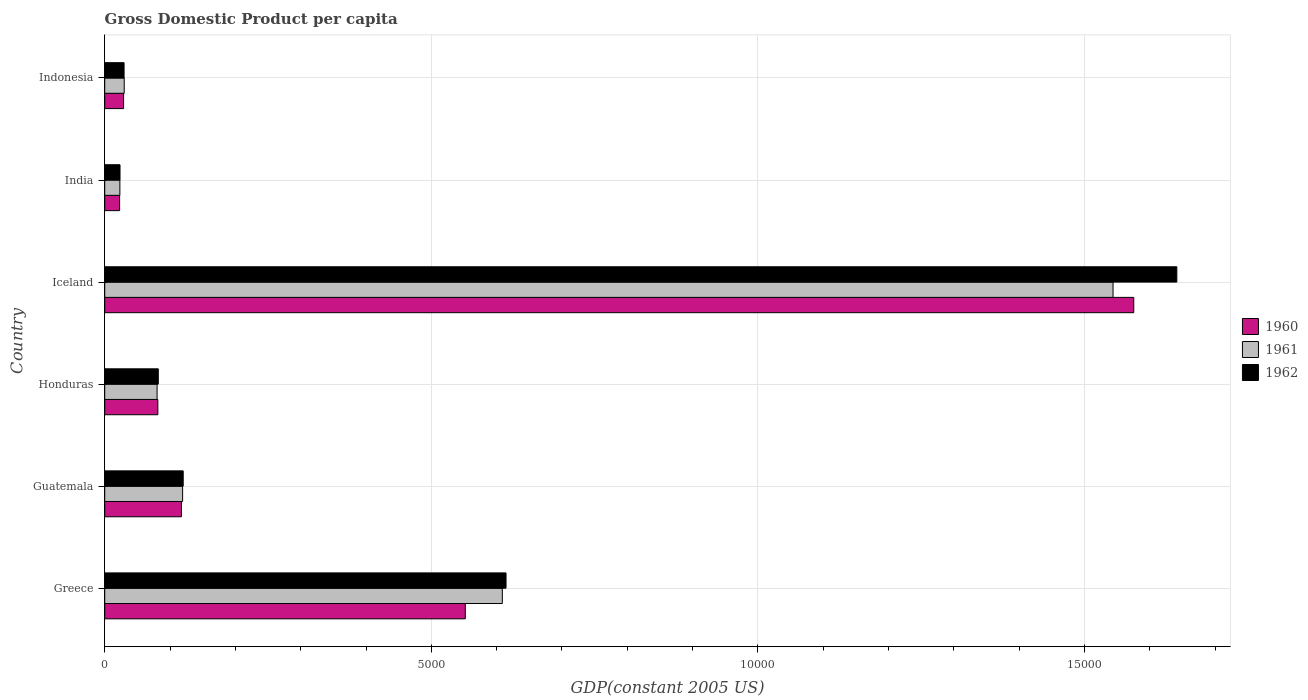How many groups of bars are there?
Keep it short and to the point. 6. Are the number of bars on each tick of the Y-axis equal?
Offer a terse response. Yes. How many bars are there on the 4th tick from the top?
Make the answer very short. 3. How many bars are there on the 4th tick from the bottom?
Your answer should be very brief. 3. What is the label of the 1st group of bars from the top?
Give a very brief answer. Indonesia. What is the GDP per capita in 1960 in Honduras?
Your answer should be compact. 813.41. Across all countries, what is the maximum GDP per capita in 1960?
Your response must be concise. 1.58e+04. Across all countries, what is the minimum GDP per capita in 1962?
Your answer should be compact. 234.17. What is the total GDP per capita in 1961 in the graph?
Provide a short and direct response. 2.40e+04. What is the difference between the GDP per capita in 1962 in Honduras and that in Iceland?
Ensure brevity in your answer.  -1.56e+04. What is the difference between the GDP per capita in 1962 in Honduras and the GDP per capita in 1961 in Indonesia?
Provide a succinct answer. 521.57. What is the average GDP per capita in 1961 per country?
Your answer should be very brief. 4008.09. What is the difference between the GDP per capita in 1961 and GDP per capita in 1962 in India?
Provide a short and direct response. -2.02. In how many countries, is the GDP per capita in 1960 greater than 13000 US$?
Make the answer very short. 1. What is the ratio of the GDP per capita in 1961 in Greece to that in India?
Your answer should be compact. 26.22. Is the difference between the GDP per capita in 1961 in Honduras and Indonesia greater than the difference between the GDP per capita in 1962 in Honduras and Indonesia?
Make the answer very short. No. What is the difference between the highest and the second highest GDP per capita in 1961?
Provide a succinct answer. 9349.4. What is the difference between the highest and the lowest GDP per capita in 1962?
Your answer should be very brief. 1.62e+04. In how many countries, is the GDP per capita in 1960 greater than the average GDP per capita in 1960 taken over all countries?
Your answer should be very brief. 2. Is the sum of the GDP per capita in 1961 in Greece and India greater than the maximum GDP per capita in 1960 across all countries?
Ensure brevity in your answer.  No. What does the 2nd bar from the top in Iceland represents?
Ensure brevity in your answer.  1961. What does the 1st bar from the bottom in Honduras represents?
Your answer should be very brief. 1960. Does the graph contain grids?
Offer a terse response. Yes. Where does the legend appear in the graph?
Offer a terse response. Center right. How are the legend labels stacked?
Ensure brevity in your answer.  Vertical. What is the title of the graph?
Make the answer very short. Gross Domestic Product per capita. Does "1995" appear as one of the legend labels in the graph?
Provide a short and direct response. No. What is the label or title of the X-axis?
Your answer should be very brief. GDP(constant 2005 US). What is the GDP(constant 2005 US) of 1960 in Greece?
Your response must be concise. 5520.09. What is the GDP(constant 2005 US) in 1961 in Greece?
Make the answer very short. 6087.1. What is the GDP(constant 2005 US) of 1962 in Greece?
Give a very brief answer. 6143.73. What is the GDP(constant 2005 US) in 1960 in Guatemala?
Your answer should be very brief. 1174.44. What is the GDP(constant 2005 US) of 1961 in Guatemala?
Provide a short and direct response. 1192.42. What is the GDP(constant 2005 US) in 1962 in Guatemala?
Offer a very short reply. 1201.57. What is the GDP(constant 2005 US) of 1960 in Honduras?
Make the answer very short. 813.41. What is the GDP(constant 2005 US) of 1961 in Honduras?
Ensure brevity in your answer.  801.77. What is the GDP(constant 2005 US) in 1962 in Honduras?
Offer a terse response. 820.2. What is the GDP(constant 2005 US) in 1960 in Iceland?
Ensure brevity in your answer.  1.58e+04. What is the GDP(constant 2005 US) of 1961 in Iceland?
Your answer should be compact. 1.54e+04. What is the GDP(constant 2005 US) in 1962 in Iceland?
Your response must be concise. 1.64e+04. What is the GDP(constant 2005 US) of 1960 in India?
Offer a very short reply. 228.3. What is the GDP(constant 2005 US) of 1961 in India?
Keep it short and to the point. 232.14. What is the GDP(constant 2005 US) in 1962 in India?
Provide a short and direct response. 234.17. What is the GDP(constant 2005 US) in 1960 in Indonesia?
Your response must be concise. 288.96. What is the GDP(constant 2005 US) of 1961 in Indonesia?
Make the answer very short. 298.63. What is the GDP(constant 2005 US) of 1962 in Indonesia?
Your response must be concise. 296.37. Across all countries, what is the maximum GDP(constant 2005 US) of 1960?
Keep it short and to the point. 1.58e+04. Across all countries, what is the maximum GDP(constant 2005 US) of 1961?
Provide a short and direct response. 1.54e+04. Across all countries, what is the maximum GDP(constant 2005 US) in 1962?
Ensure brevity in your answer.  1.64e+04. Across all countries, what is the minimum GDP(constant 2005 US) of 1960?
Provide a short and direct response. 228.3. Across all countries, what is the minimum GDP(constant 2005 US) in 1961?
Offer a very short reply. 232.14. Across all countries, what is the minimum GDP(constant 2005 US) of 1962?
Give a very brief answer. 234.17. What is the total GDP(constant 2005 US) of 1960 in the graph?
Provide a short and direct response. 2.38e+04. What is the total GDP(constant 2005 US) in 1961 in the graph?
Your answer should be very brief. 2.40e+04. What is the total GDP(constant 2005 US) in 1962 in the graph?
Your answer should be compact. 2.51e+04. What is the difference between the GDP(constant 2005 US) of 1960 in Greece and that in Guatemala?
Your response must be concise. 4345.65. What is the difference between the GDP(constant 2005 US) in 1961 in Greece and that in Guatemala?
Make the answer very short. 4894.68. What is the difference between the GDP(constant 2005 US) in 1962 in Greece and that in Guatemala?
Provide a succinct answer. 4942.16. What is the difference between the GDP(constant 2005 US) in 1960 in Greece and that in Honduras?
Provide a short and direct response. 4706.68. What is the difference between the GDP(constant 2005 US) of 1961 in Greece and that in Honduras?
Your response must be concise. 5285.32. What is the difference between the GDP(constant 2005 US) of 1962 in Greece and that in Honduras?
Offer a very short reply. 5323.53. What is the difference between the GDP(constant 2005 US) in 1960 in Greece and that in Iceland?
Your response must be concise. -1.02e+04. What is the difference between the GDP(constant 2005 US) in 1961 in Greece and that in Iceland?
Your answer should be very brief. -9349.4. What is the difference between the GDP(constant 2005 US) in 1962 in Greece and that in Iceland?
Keep it short and to the point. -1.03e+04. What is the difference between the GDP(constant 2005 US) in 1960 in Greece and that in India?
Ensure brevity in your answer.  5291.78. What is the difference between the GDP(constant 2005 US) in 1961 in Greece and that in India?
Provide a succinct answer. 5854.95. What is the difference between the GDP(constant 2005 US) of 1962 in Greece and that in India?
Keep it short and to the point. 5909.56. What is the difference between the GDP(constant 2005 US) of 1960 in Greece and that in Indonesia?
Your response must be concise. 5231.12. What is the difference between the GDP(constant 2005 US) in 1961 in Greece and that in Indonesia?
Provide a succinct answer. 5788.47. What is the difference between the GDP(constant 2005 US) of 1962 in Greece and that in Indonesia?
Offer a very short reply. 5847.36. What is the difference between the GDP(constant 2005 US) of 1960 in Guatemala and that in Honduras?
Your answer should be very brief. 361.03. What is the difference between the GDP(constant 2005 US) of 1961 in Guatemala and that in Honduras?
Your response must be concise. 390.64. What is the difference between the GDP(constant 2005 US) of 1962 in Guatemala and that in Honduras?
Keep it short and to the point. 381.38. What is the difference between the GDP(constant 2005 US) of 1960 in Guatemala and that in Iceland?
Offer a terse response. -1.46e+04. What is the difference between the GDP(constant 2005 US) in 1961 in Guatemala and that in Iceland?
Ensure brevity in your answer.  -1.42e+04. What is the difference between the GDP(constant 2005 US) of 1962 in Guatemala and that in Iceland?
Keep it short and to the point. -1.52e+04. What is the difference between the GDP(constant 2005 US) of 1960 in Guatemala and that in India?
Your answer should be compact. 946.14. What is the difference between the GDP(constant 2005 US) in 1961 in Guatemala and that in India?
Provide a short and direct response. 960.28. What is the difference between the GDP(constant 2005 US) in 1962 in Guatemala and that in India?
Your answer should be very brief. 967.41. What is the difference between the GDP(constant 2005 US) in 1960 in Guatemala and that in Indonesia?
Your answer should be compact. 885.48. What is the difference between the GDP(constant 2005 US) in 1961 in Guatemala and that in Indonesia?
Provide a short and direct response. 893.79. What is the difference between the GDP(constant 2005 US) in 1962 in Guatemala and that in Indonesia?
Offer a terse response. 905.2. What is the difference between the GDP(constant 2005 US) of 1960 in Honduras and that in Iceland?
Keep it short and to the point. -1.49e+04. What is the difference between the GDP(constant 2005 US) of 1961 in Honduras and that in Iceland?
Make the answer very short. -1.46e+04. What is the difference between the GDP(constant 2005 US) in 1962 in Honduras and that in Iceland?
Give a very brief answer. -1.56e+04. What is the difference between the GDP(constant 2005 US) in 1960 in Honduras and that in India?
Your response must be concise. 585.1. What is the difference between the GDP(constant 2005 US) in 1961 in Honduras and that in India?
Your answer should be very brief. 569.63. What is the difference between the GDP(constant 2005 US) of 1962 in Honduras and that in India?
Give a very brief answer. 586.03. What is the difference between the GDP(constant 2005 US) in 1960 in Honduras and that in Indonesia?
Provide a succinct answer. 524.45. What is the difference between the GDP(constant 2005 US) in 1961 in Honduras and that in Indonesia?
Offer a very short reply. 503.15. What is the difference between the GDP(constant 2005 US) in 1962 in Honduras and that in Indonesia?
Provide a succinct answer. 523.83. What is the difference between the GDP(constant 2005 US) of 1960 in Iceland and that in India?
Your response must be concise. 1.55e+04. What is the difference between the GDP(constant 2005 US) of 1961 in Iceland and that in India?
Offer a very short reply. 1.52e+04. What is the difference between the GDP(constant 2005 US) of 1962 in Iceland and that in India?
Provide a succinct answer. 1.62e+04. What is the difference between the GDP(constant 2005 US) in 1960 in Iceland and that in Indonesia?
Keep it short and to the point. 1.55e+04. What is the difference between the GDP(constant 2005 US) in 1961 in Iceland and that in Indonesia?
Offer a very short reply. 1.51e+04. What is the difference between the GDP(constant 2005 US) in 1962 in Iceland and that in Indonesia?
Your response must be concise. 1.61e+04. What is the difference between the GDP(constant 2005 US) of 1960 in India and that in Indonesia?
Ensure brevity in your answer.  -60.66. What is the difference between the GDP(constant 2005 US) in 1961 in India and that in Indonesia?
Make the answer very short. -66.48. What is the difference between the GDP(constant 2005 US) of 1962 in India and that in Indonesia?
Offer a very short reply. -62.21. What is the difference between the GDP(constant 2005 US) in 1960 in Greece and the GDP(constant 2005 US) in 1961 in Guatemala?
Your response must be concise. 4327.67. What is the difference between the GDP(constant 2005 US) in 1960 in Greece and the GDP(constant 2005 US) in 1962 in Guatemala?
Your answer should be compact. 4318.51. What is the difference between the GDP(constant 2005 US) of 1961 in Greece and the GDP(constant 2005 US) of 1962 in Guatemala?
Offer a very short reply. 4885.52. What is the difference between the GDP(constant 2005 US) of 1960 in Greece and the GDP(constant 2005 US) of 1961 in Honduras?
Your answer should be very brief. 4718.31. What is the difference between the GDP(constant 2005 US) of 1960 in Greece and the GDP(constant 2005 US) of 1962 in Honduras?
Offer a very short reply. 4699.89. What is the difference between the GDP(constant 2005 US) in 1961 in Greece and the GDP(constant 2005 US) in 1962 in Honduras?
Offer a very short reply. 5266.9. What is the difference between the GDP(constant 2005 US) in 1960 in Greece and the GDP(constant 2005 US) in 1961 in Iceland?
Your answer should be very brief. -9916.41. What is the difference between the GDP(constant 2005 US) in 1960 in Greece and the GDP(constant 2005 US) in 1962 in Iceland?
Provide a short and direct response. -1.09e+04. What is the difference between the GDP(constant 2005 US) in 1961 in Greece and the GDP(constant 2005 US) in 1962 in Iceland?
Offer a very short reply. -1.03e+04. What is the difference between the GDP(constant 2005 US) of 1960 in Greece and the GDP(constant 2005 US) of 1961 in India?
Give a very brief answer. 5287.95. What is the difference between the GDP(constant 2005 US) in 1960 in Greece and the GDP(constant 2005 US) in 1962 in India?
Keep it short and to the point. 5285.92. What is the difference between the GDP(constant 2005 US) of 1961 in Greece and the GDP(constant 2005 US) of 1962 in India?
Your response must be concise. 5852.93. What is the difference between the GDP(constant 2005 US) in 1960 in Greece and the GDP(constant 2005 US) in 1961 in Indonesia?
Provide a succinct answer. 5221.46. What is the difference between the GDP(constant 2005 US) of 1960 in Greece and the GDP(constant 2005 US) of 1962 in Indonesia?
Provide a short and direct response. 5223.72. What is the difference between the GDP(constant 2005 US) of 1961 in Greece and the GDP(constant 2005 US) of 1962 in Indonesia?
Give a very brief answer. 5790.72. What is the difference between the GDP(constant 2005 US) in 1960 in Guatemala and the GDP(constant 2005 US) in 1961 in Honduras?
Keep it short and to the point. 372.67. What is the difference between the GDP(constant 2005 US) of 1960 in Guatemala and the GDP(constant 2005 US) of 1962 in Honduras?
Your response must be concise. 354.24. What is the difference between the GDP(constant 2005 US) in 1961 in Guatemala and the GDP(constant 2005 US) in 1962 in Honduras?
Your answer should be compact. 372.22. What is the difference between the GDP(constant 2005 US) in 1960 in Guatemala and the GDP(constant 2005 US) in 1961 in Iceland?
Ensure brevity in your answer.  -1.43e+04. What is the difference between the GDP(constant 2005 US) in 1960 in Guatemala and the GDP(constant 2005 US) in 1962 in Iceland?
Give a very brief answer. -1.52e+04. What is the difference between the GDP(constant 2005 US) of 1961 in Guatemala and the GDP(constant 2005 US) of 1962 in Iceland?
Your answer should be very brief. -1.52e+04. What is the difference between the GDP(constant 2005 US) of 1960 in Guatemala and the GDP(constant 2005 US) of 1961 in India?
Keep it short and to the point. 942.3. What is the difference between the GDP(constant 2005 US) in 1960 in Guatemala and the GDP(constant 2005 US) in 1962 in India?
Your answer should be compact. 940.28. What is the difference between the GDP(constant 2005 US) in 1961 in Guatemala and the GDP(constant 2005 US) in 1962 in India?
Your answer should be very brief. 958.25. What is the difference between the GDP(constant 2005 US) in 1960 in Guatemala and the GDP(constant 2005 US) in 1961 in Indonesia?
Provide a short and direct response. 875.82. What is the difference between the GDP(constant 2005 US) in 1960 in Guatemala and the GDP(constant 2005 US) in 1962 in Indonesia?
Provide a succinct answer. 878.07. What is the difference between the GDP(constant 2005 US) in 1961 in Guatemala and the GDP(constant 2005 US) in 1962 in Indonesia?
Make the answer very short. 896.04. What is the difference between the GDP(constant 2005 US) of 1960 in Honduras and the GDP(constant 2005 US) of 1961 in Iceland?
Give a very brief answer. -1.46e+04. What is the difference between the GDP(constant 2005 US) in 1960 in Honduras and the GDP(constant 2005 US) in 1962 in Iceland?
Your answer should be compact. -1.56e+04. What is the difference between the GDP(constant 2005 US) of 1961 in Honduras and the GDP(constant 2005 US) of 1962 in Iceland?
Your answer should be very brief. -1.56e+04. What is the difference between the GDP(constant 2005 US) in 1960 in Honduras and the GDP(constant 2005 US) in 1961 in India?
Keep it short and to the point. 581.27. What is the difference between the GDP(constant 2005 US) of 1960 in Honduras and the GDP(constant 2005 US) of 1962 in India?
Your response must be concise. 579.24. What is the difference between the GDP(constant 2005 US) of 1961 in Honduras and the GDP(constant 2005 US) of 1962 in India?
Make the answer very short. 567.61. What is the difference between the GDP(constant 2005 US) in 1960 in Honduras and the GDP(constant 2005 US) in 1961 in Indonesia?
Your answer should be very brief. 514.78. What is the difference between the GDP(constant 2005 US) of 1960 in Honduras and the GDP(constant 2005 US) of 1962 in Indonesia?
Offer a very short reply. 517.04. What is the difference between the GDP(constant 2005 US) in 1961 in Honduras and the GDP(constant 2005 US) in 1962 in Indonesia?
Make the answer very short. 505.4. What is the difference between the GDP(constant 2005 US) of 1960 in Iceland and the GDP(constant 2005 US) of 1961 in India?
Offer a very short reply. 1.55e+04. What is the difference between the GDP(constant 2005 US) in 1960 in Iceland and the GDP(constant 2005 US) in 1962 in India?
Offer a terse response. 1.55e+04. What is the difference between the GDP(constant 2005 US) in 1961 in Iceland and the GDP(constant 2005 US) in 1962 in India?
Your answer should be compact. 1.52e+04. What is the difference between the GDP(constant 2005 US) of 1960 in Iceland and the GDP(constant 2005 US) of 1961 in Indonesia?
Give a very brief answer. 1.55e+04. What is the difference between the GDP(constant 2005 US) of 1960 in Iceland and the GDP(constant 2005 US) of 1962 in Indonesia?
Offer a very short reply. 1.55e+04. What is the difference between the GDP(constant 2005 US) of 1961 in Iceland and the GDP(constant 2005 US) of 1962 in Indonesia?
Offer a terse response. 1.51e+04. What is the difference between the GDP(constant 2005 US) of 1960 in India and the GDP(constant 2005 US) of 1961 in Indonesia?
Make the answer very short. -70.32. What is the difference between the GDP(constant 2005 US) of 1960 in India and the GDP(constant 2005 US) of 1962 in Indonesia?
Make the answer very short. -68.07. What is the difference between the GDP(constant 2005 US) in 1961 in India and the GDP(constant 2005 US) in 1962 in Indonesia?
Keep it short and to the point. -64.23. What is the average GDP(constant 2005 US) of 1960 per country?
Make the answer very short. 3963.13. What is the average GDP(constant 2005 US) in 1961 per country?
Your answer should be very brief. 4008.09. What is the average GDP(constant 2005 US) in 1962 per country?
Keep it short and to the point. 4184.81. What is the difference between the GDP(constant 2005 US) in 1960 and GDP(constant 2005 US) in 1961 in Greece?
Provide a succinct answer. -567.01. What is the difference between the GDP(constant 2005 US) in 1960 and GDP(constant 2005 US) in 1962 in Greece?
Make the answer very short. -623.64. What is the difference between the GDP(constant 2005 US) in 1961 and GDP(constant 2005 US) in 1962 in Greece?
Ensure brevity in your answer.  -56.63. What is the difference between the GDP(constant 2005 US) of 1960 and GDP(constant 2005 US) of 1961 in Guatemala?
Offer a terse response. -17.97. What is the difference between the GDP(constant 2005 US) of 1960 and GDP(constant 2005 US) of 1962 in Guatemala?
Your answer should be very brief. -27.13. What is the difference between the GDP(constant 2005 US) in 1961 and GDP(constant 2005 US) in 1962 in Guatemala?
Provide a short and direct response. -9.16. What is the difference between the GDP(constant 2005 US) of 1960 and GDP(constant 2005 US) of 1961 in Honduras?
Ensure brevity in your answer.  11.63. What is the difference between the GDP(constant 2005 US) in 1960 and GDP(constant 2005 US) in 1962 in Honduras?
Offer a very short reply. -6.79. What is the difference between the GDP(constant 2005 US) of 1961 and GDP(constant 2005 US) of 1962 in Honduras?
Offer a very short reply. -18.42. What is the difference between the GDP(constant 2005 US) of 1960 and GDP(constant 2005 US) of 1961 in Iceland?
Your response must be concise. 317.1. What is the difference between the GDP(constant 2005 US) of 1960 and GDP(constant 2005 US) of 1962 in Iceland?
Offer a very short reply. -659.22. What is the difference between the GDP(constant 2005 US) in 1961 and GDP(constant 2005 US) in 1962 in Iceland?
Your answer should be very brief. -976.32. What is the difference between the GDP(constant 2005 US) of 1960 and GDP(constant 2005 US) of 1961 in India?
Provide a short and direct response. -3.84. What is the difference between the GDP(constant 2005 US) in 1960 and GDP(constant 2005 US) in 1962 in India?
Your response must be concise. -5.86. What is the difference between the GDP(constant 2005 US) in 1961 and GDP(constant 2005 US) in 1962 in India?
Your answer should be very brief. -2.02. What is the difference between the GDP(constant 2005 US) of 1960 and GDP(constant 2005 US) of 1961 in Indonesia?
Give a very brief answer. -9.66. What is the difference between the GDP(constant 2005 US) of 1960 and GDP(constant 2005 US) of 1962 in Indonesia?
Provide a short and direct response. -7.41. What is the difference between the GDP(constant 2005 US) in 1961 and GDP(constant 2005 US) in 1962 in Indonesia?
Give a very brief answer. 2.25. What is the ratio of the GDP(constant 2005 US) of 1960 in Greece to that in Guatemala?
Provide a succinct answer. 4.7. What is the ratio of the GDP(constant 2005 US) of 1961 in Greece to that in Guatemala?
Your response must be concise. 5.1. What is the ratio of the GDP(constant 2005 US) in 1962 in Greece to that in Guatemala?
Make the answer very short. 5.11. What is the ratio of the GDP(constant 2005 US) in 1960 in Greece to that in Honduras?
Keep it short and to the point. 6.79. What is the ratio of the GDP(constant 2005 US) of 1961 in Greece to that in Honduras?
Provide a short and direct response. 7.59. What is the ratio of the GDP(constant 2005 US) of 1962 in Greece to that in Honduras?
Your answer should be compact. 7.49. What is the ratio of the GDP(constant 2005 US) in 1960 in Greece to that in Iceland?
Provide a short and direct response. 0.35. What is the ratio of the GDP(constant 2005 US) in 1961 in Greece to that in Iceland?
Ensure brevity in your answer.  0.39. What is the ratio of the GDP(constant 2005 US) in 1962 in Greece to that in Iceland?
Provide a succinct answer. 0.37. What is the ratio of the GDP(constant 2005 US) in 1960 in Greece to that in India?
Offer a very short reply. 24.18. What is the ratio of the GDP(constant 2005 US) of 1961 in Greece to that in India?
Offer a terse response. 26.22. What is the ratio of the GDP(constant 2005 US) of 1962 in Greece to that in India?
Make the answer very short. 26.24. What is the ratio of the GDP(constant 2005 US) of 1960 in Greece to that in Indonesia?
Offer a terse response. 19.1. What is the ratio of the GDP(constant 2005 US) of 1961 in Greece to that in Indonesia?
Offer a terse response. 20.38. What is the ratio of the GDP(constant 2005 US) in 1962 in Greece to that in Indonesia?
Give a very brief answer. 20.73. What is the ratio of the GDP(constant 2005 US) in 1960 in Guatemala to that in Honduras?
Give a very brief answer. 1.44. What is the ratio of the GDP(constant 2005 US) in 1961 in Guatemala to that in Honduras?
Offer a very short reply. 1.49. What is the ratio of the GDP(constant 2005 US) in 1962 in Guatemala to that in Honduras?
Offer a terse response. 1.47. What is the ratio of the GDP(constant 2005 US) of 1960 in Guatemala to that in Iceland?
Make the answer very short. 0.07. What is the ratio of the GDP(constant 2005 US) in 1961 in Guatemala to that in Iceland?
Make the answer very short. 0.08. What is the ratio of the GDP(constant 2005 US) of 1962 in Guatemala to that in Iceland?
Offer a very short reply. 0.07. What is the ratio of the GDP(constant 2005 US) in 1960 in Guatemala to that in India?
Your response must be concise. 5.14. What is the ratio of the GDP(constant 2005 US) of 1961 in Guatemala to that in India?
Offer a very short reply. 5.14. What is the ratio of the GDP(constant 2005 US) in 1962 in Guatemala to that in India?
Provide a succinct answer. 5.13. What is the ratio of the GDP(constant 2005 US) of 1960 in Guatemala to that in Indonesia?
Make the answer very short. 4.06. What is the ratio of the GDP(constant 2005 US) in 1961 in Guatemala to that in Indonesia?
Keep it short and to the point. 3.99. What is the ratio of the GDP(constant 2005 US) in 1962 in Guatemala to that in Indonesia?
Make the answer very short. 4.05. What is the ratio of the GDP(constant 2005 US) of 1960 in Honduras to that in Iceland?
Offer a very short reply. 0.05. What is the ratio of the GDP(constant 2005 US) in 1961 in Honduras to that in Iceland?
Offer a very short reply. 0.05. What is the ratio of the GDP(constant 2005 US) in 1962 in Honduras to that in Iceland?
Your answer should be compact. 0.05. What is the ratio of the GDP(constant 2005 US) in 1960 in Honduras to that in India?
Offer a very short reply. 3.56. What is the ratio of the GDP(constant 2005 US) in 1961 in Honduras to that in India?
Offer a very short reply. 3.45. What is the ratio of the GDP(constant 2005 US) of 1962 in Honduras to that in India?
Ensure brevity in your answer.  3.5. What is the ratio of the GDP(constant 2005 US) of 1960 in Honduras to that in Indonesia?
Ensure brevity in your answer.  2.81. What is the ratio of the GDP(constant 2005 US) in 1961 in Honduras to that in Indonesia?
Provide a short and direct response. 2.68. What is the ratio of the GDP(constant 2005 US) of 1962 in Honduras to that in Indonesia?
Make the answer very short. 2.77. What is the ratio of the GDP(constant 2005 US) of 1960 in Iceland to that in India?
Your answer should be compact. 69. What is the ratio of the GDP(constant 2005 US) of 1961 in Iceland to that in India?
Provide a short and direct response. 66.5. What is the ratio of the GDP(constant 2005 US) of 1962 in Iceland to that in India?
Your answer should be very brief. 70.09. What is the ratio of the GDP(constant 2005 US) of 1960 in Iceland to that in Indonesia?
Your answer should be compact. 54.52. What is the ratio of the GDP(constant 2005 US) in 1961 in Iceland to that in Indonesia?
Your response must be concise. 51.69. What is the ratio of the GDP(constant 2005 US) in 1962 in Iceland to that in Indonesia?
Your answer should be very brief. 55.38. What is the ratio of the GDP(constant 2005 US) in 1960 in India to that in Indonesia?
Provide a succinct answer. 0.79. What is the ratio of the GDP(constant 2005 US) in 1961 in India to that in Indonesia?
Your response must be concise. 0.78. What is the ratio of the GDP(constant 2005 US) in 1962 in India to that in Indonesia?
Your answer should be compact. 0.79. What is the difference between the highest and the second highest GDP(constant 2005 US) of 1960?
Provide a short and direct response. 1.02e+04. What is the difference between the highest and the second highest GDP(constant 2005 US) of 1961?
Your response must be concise. 9349.4. What is the difference between the highest and the second highest GDP(constant 2005 US) of 1962?
Make the answer very short. 1.03e+04. What is the difference between the highest and the lowest GDP(constant 2005 US) of 1960?
Your answer should be compact. 1.55e+04. What is the difference between the highest and the lowest GDP(constant 2005 US) in 1961?
Offer a very short reply. 1.52e+04. What is the difference between the highest and the lowest GDP(constant 2005 US) of 1962?
Your answer should be very brief. 1.62e+04. 